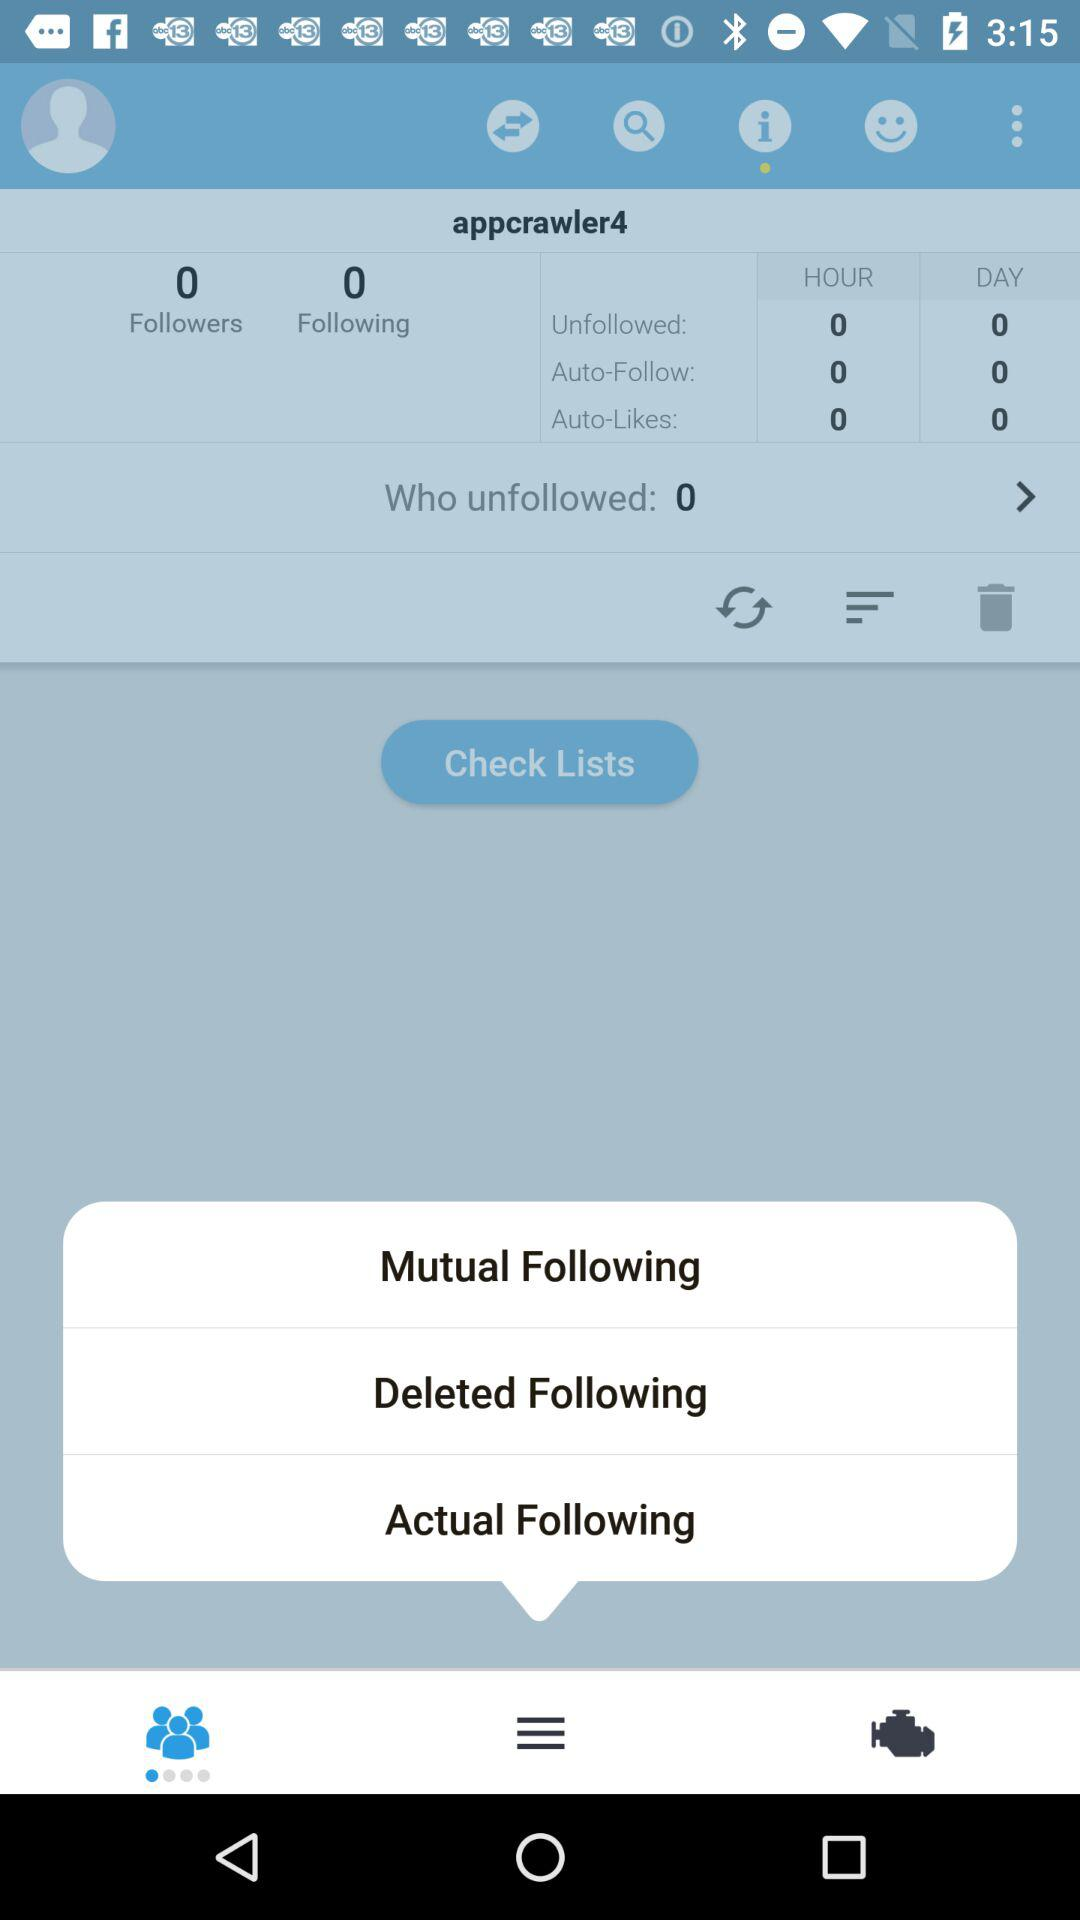What is the number of people who unfollowed "appcrawler4"? The number of people who unfollowed "appcrawler4" is 0. 